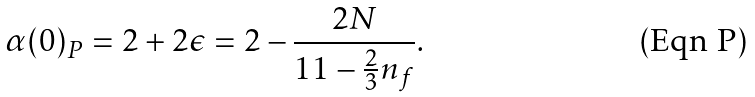<formula> <loc_0><loc_0><loc_500><loc_500>\alpha ( 0 ) _ { P } = 2 + 2 \epsilon = 2 - \frac { 2 N } { 1 1 - \frac { 2 } { 3 } n _ { f } } .</formula> 